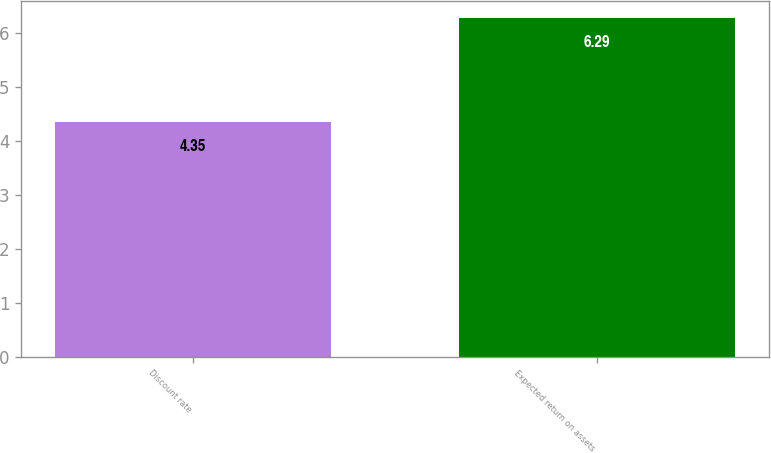Convert chart to OTSL. <chart><loc_0><loc_0><loc_500><loc_500><bar_chart><fcel>Discount rate<fcel>Expected return on assets<nl><fcel>4.35<fcel>6.29<nl></chart> 